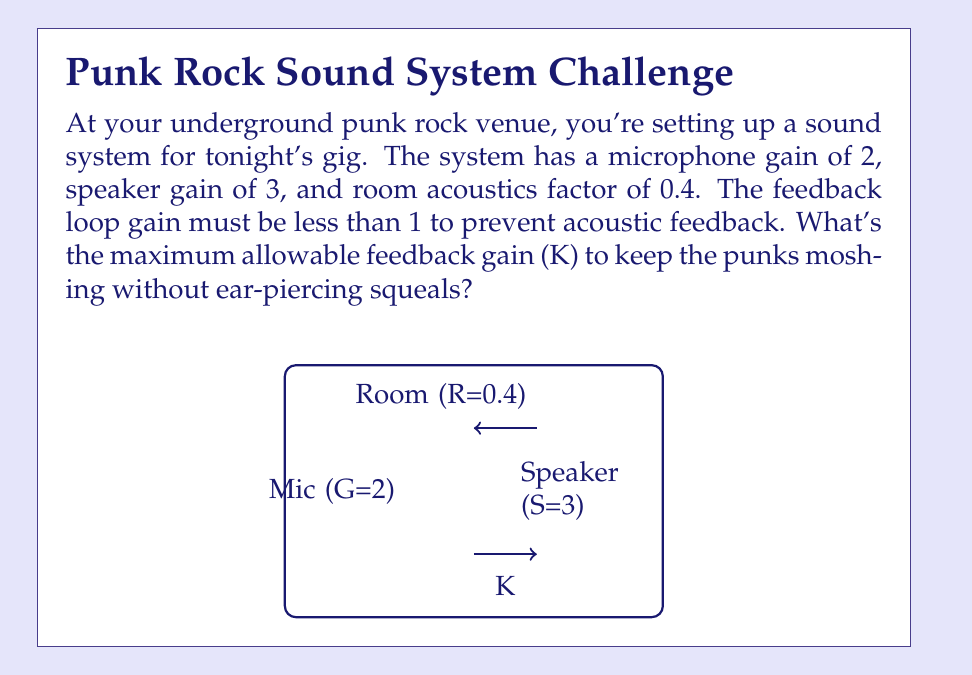Can you solve this math problem? Let's approach this step-by-step:

1) In a sound system, the loop gain is the product of all gains in the feedback loop. Here, it's:

   Loop Gain = Microphone Gain × Speaker Gain × Room Acoustics × Feedback Gain
   
   $$ \text{Loop Gain} = G \times S \times R \times K $$

2) To prevent acoustic feedback, the loop gain must be less than 1:

   $$ G \times S \times R \times K < 1 $$

3) We're given:
   G (Microphone Gain) = 2
   S (Speaker Gain) = 3
   R (Room Acoustics) = 0.4

4) Substituting these values:

   $$ 2 \times 3 \times 0.4 \times K < 1 $$

5) Simplify:

   $$ 2.4K < 1 $$

6) Solve for K:

   $$ K < \frac{1}{2.4} $$
   $$ K < 0.4166... $$

7) The maximum allowable K is just below this value. In practice, we'd round down slightly for safety.
Answer: $K = 0.416$ 